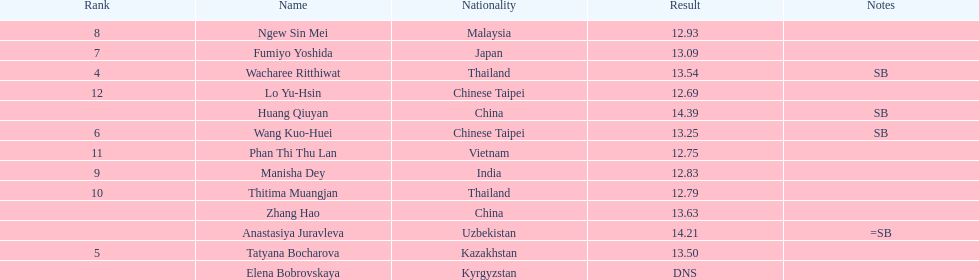How many athletes had a better result than tatyana bocharova? 4. 